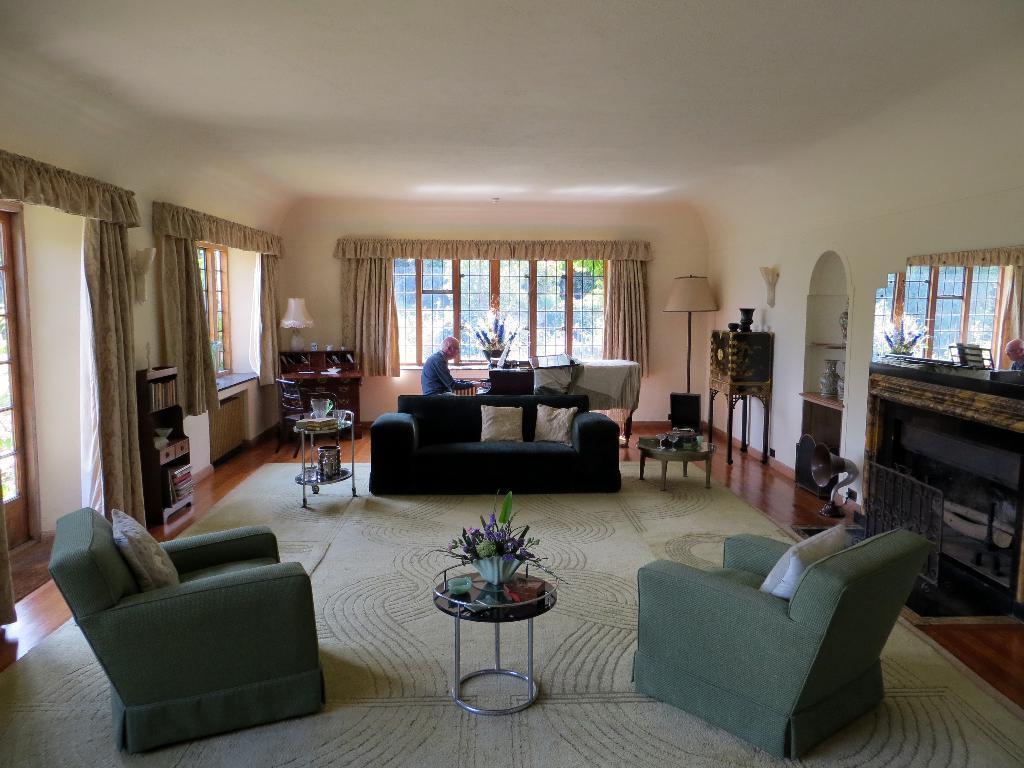Can you describe this image briefly? This picture is taken in a room, There are some sofas in green color, In the middle there is a table on that there is a object kept, In the background there is a black color sofa, There is a person sitting and playing a piano which is in black color, There is a window which is in brown color, There is a white color roof in the top. 